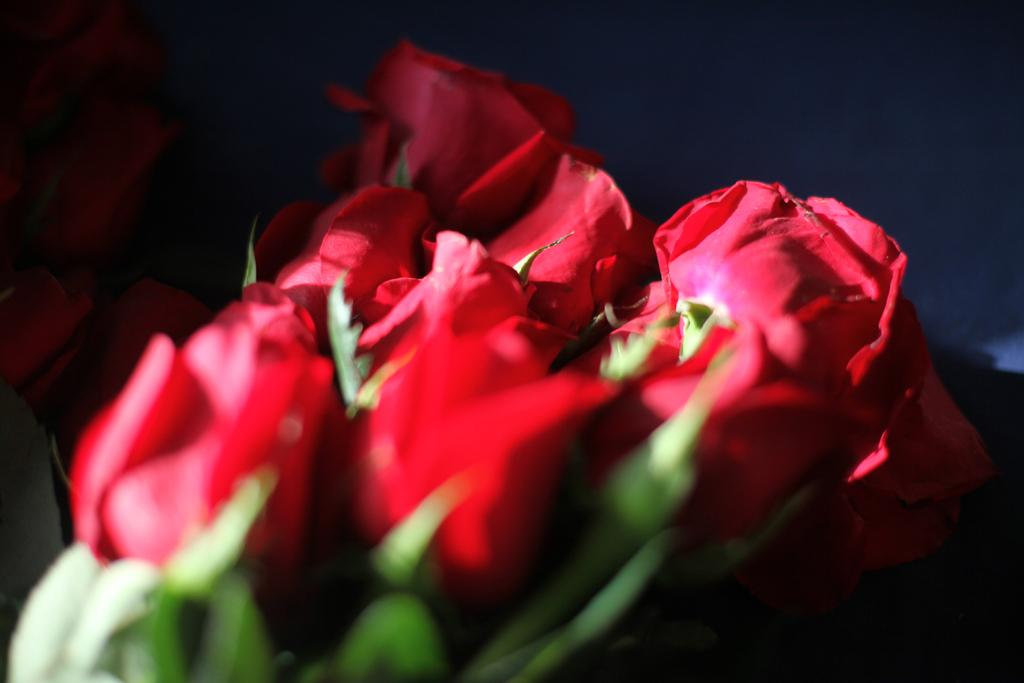What type of flowers are in the image? There are red roses in the image. Are there any other flowers visible in the image? Yes, there are additional roses in the background. How would you describe the background of the image? The background is dark. What parts of the roses can be seen in the image? The roses have stems and leaves. What type of payment is required to obtain the roses in the image? There is no mention of payment or obtaining the roses in the image; it simply depicts red roses with stems and leaves. 